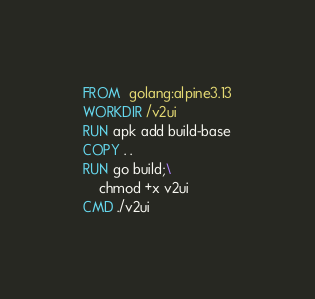<code> <loc_0><loc_0><loc_500><loc_500><_Dockerfile_>FROM  golang:alpine3.13
WORKDIR /v2ui
RUN apk add build-base
COPY . .
RUN go build;\
    chmod +x v2ui
CMD ./v2ui
</code> 